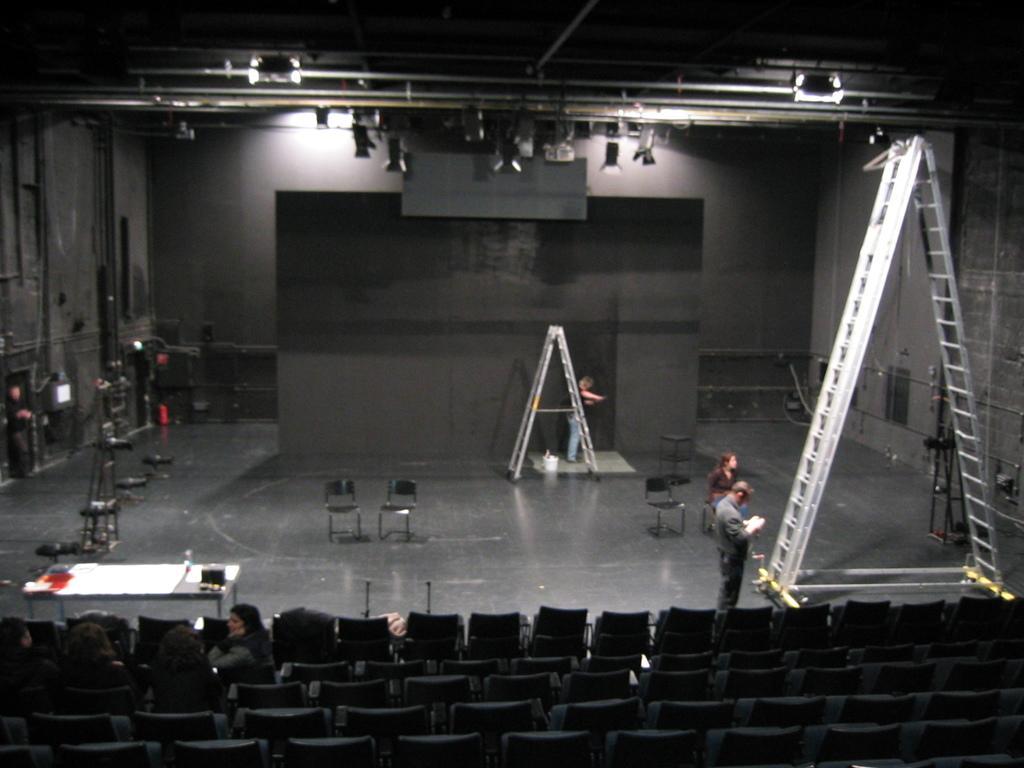Describe this image in one or two sentences. In the foreground of the image we can see a group of people sitting on chairs. To the right side of the image we can see two persons standing on the floor and a ladder is placed on the floor. In the center of the image we can see two chairs placed on the floor. In the background, we can see a person standing and a screen and group of lights placed on the ceiling. 